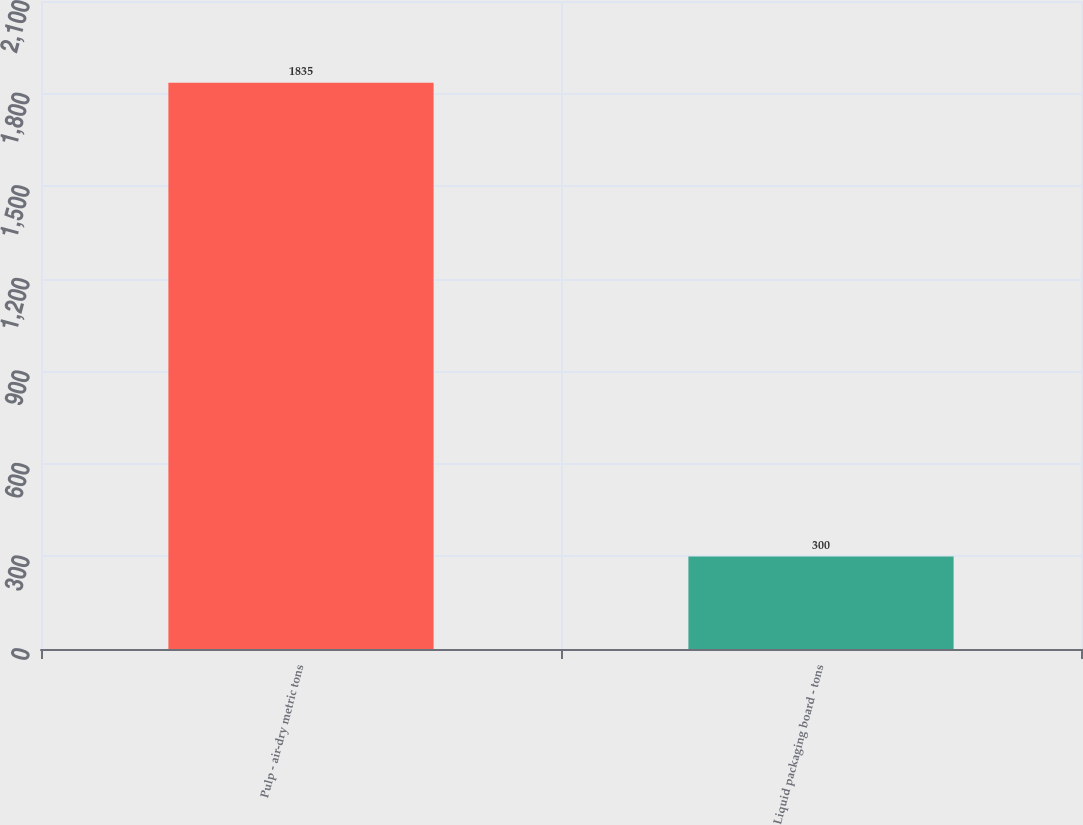<chart> <loc_0><loc_0><loc_500><loc_500><bar_chart><fcel>Pulp - air-dry metric tons<fcel>Liquid packaging board - tons<nl><fcel>1835<fcel>300<nl></chart> 